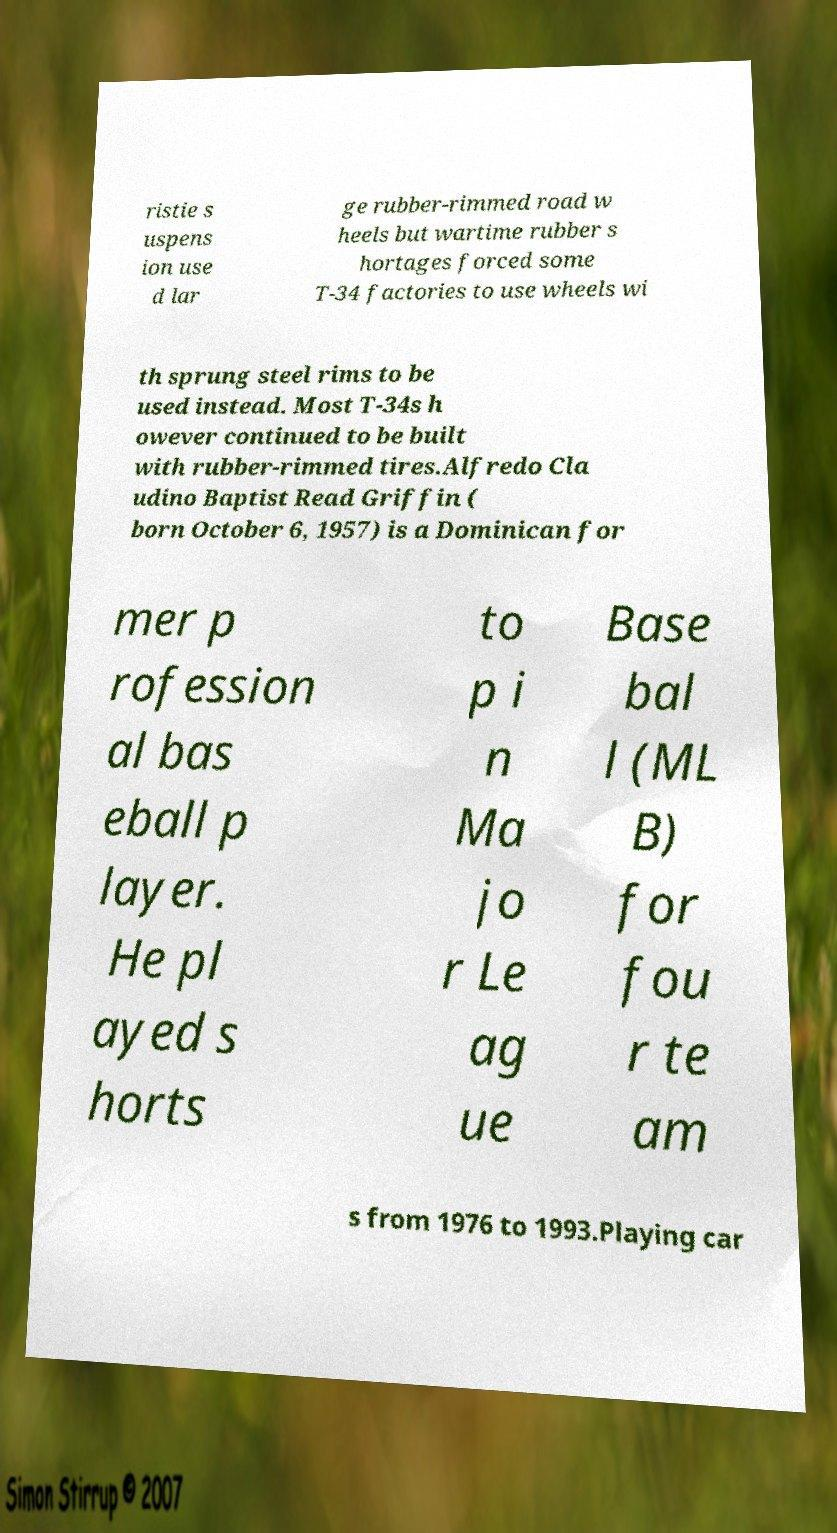For documentation purposes, I need the text within this image transcribed. Could you provide that? ristie s uspens ion use d lar ge rubber-rimmed road w heels but wartime rubber s hortages forced some T-34 factories to use wheels wi th sprung steel rims to be used instead. Most T-34s h owever continued to be built with rubber-rimmed tires.Alfredo Cla udino Baptist Read Griffin ( born October 6, 1957) is a Dominican for mer p rofession al bas eball p layer. He pl ayed s horts to p i n Ma jo r Le ag ue Base bal l (ML B) for fou r te am s from 1976 to 1993.Playing car 